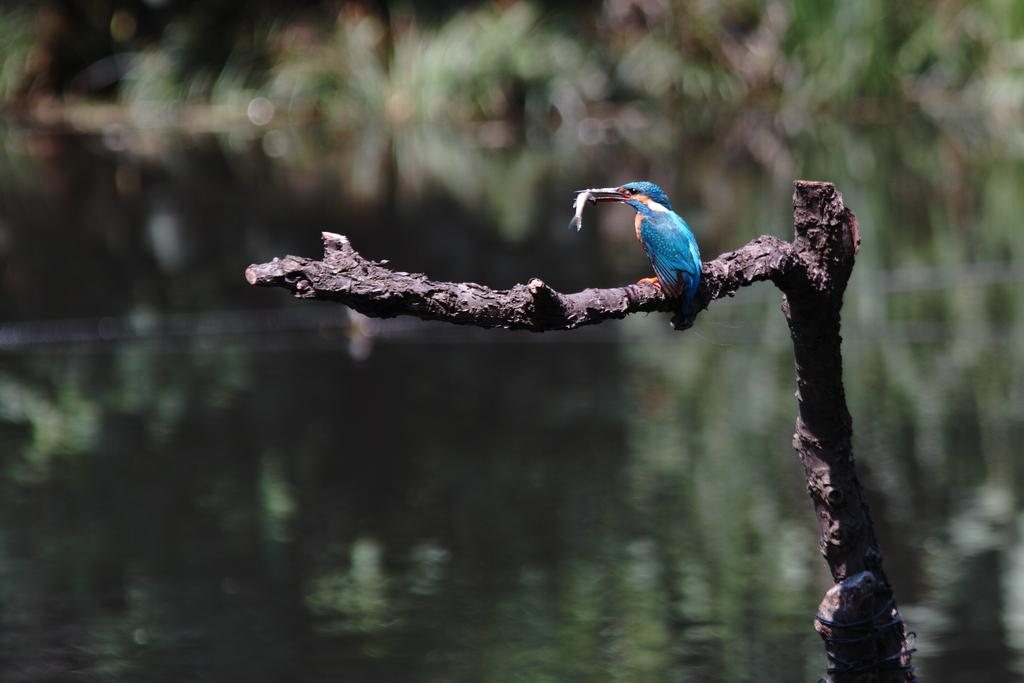What type of animal can be seen in the image? There is a bird in the image. What is the bird doing in the image? The bird is holding a fish in its mouth. Where is the bird located in the image? The bird is on a tree branch. What can be seen in the background of the image? The background is blurred. How many friends does the bird have on its journey in the image? There is no indication of a journey or friends in the image; it simply shows a bird holding a fish on a tree branch. 